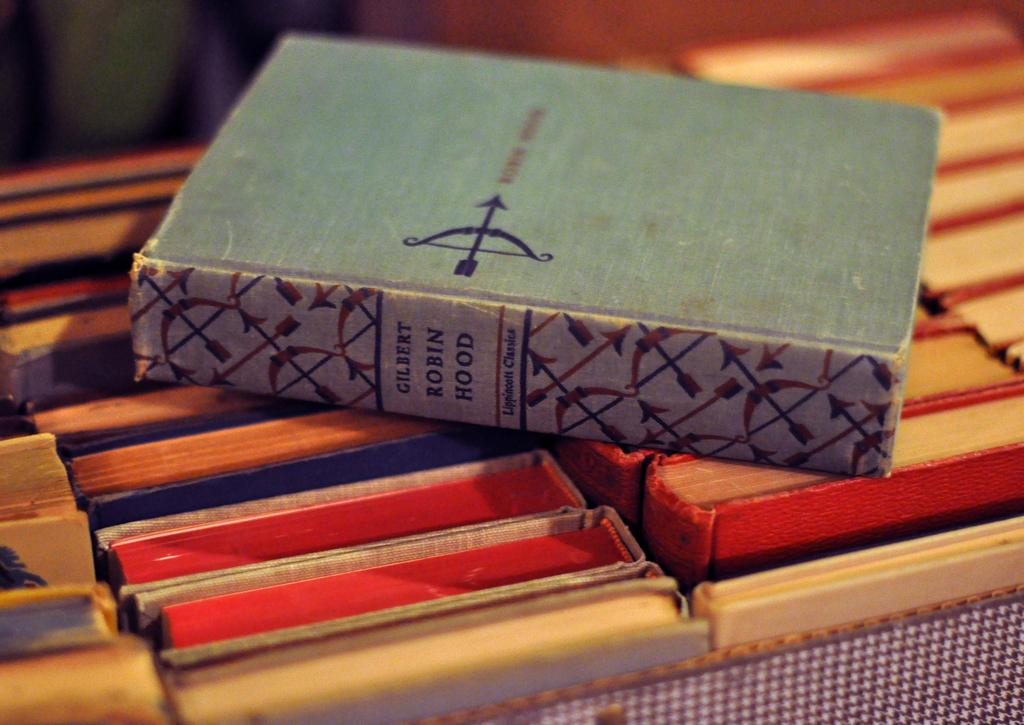<image>
Present a compact description of the photo's key features. The book Robin Hood is laying on a box of many other books 